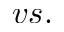Convert formula to latex. <formula><loc_0><loc_0><loc_500><loc_500>v s .</formula> 